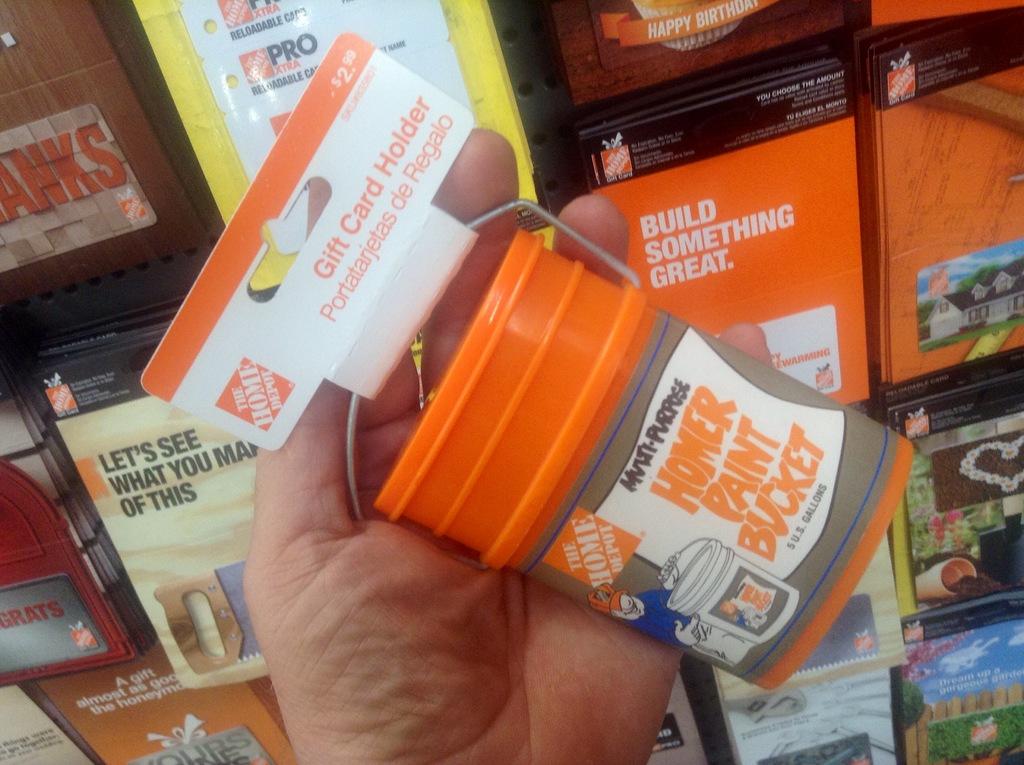What is the bucket intended to hold?
Keep it short and to the point. Paint. What store sells this paint bucket?
Your response must be concise. Home depot. 